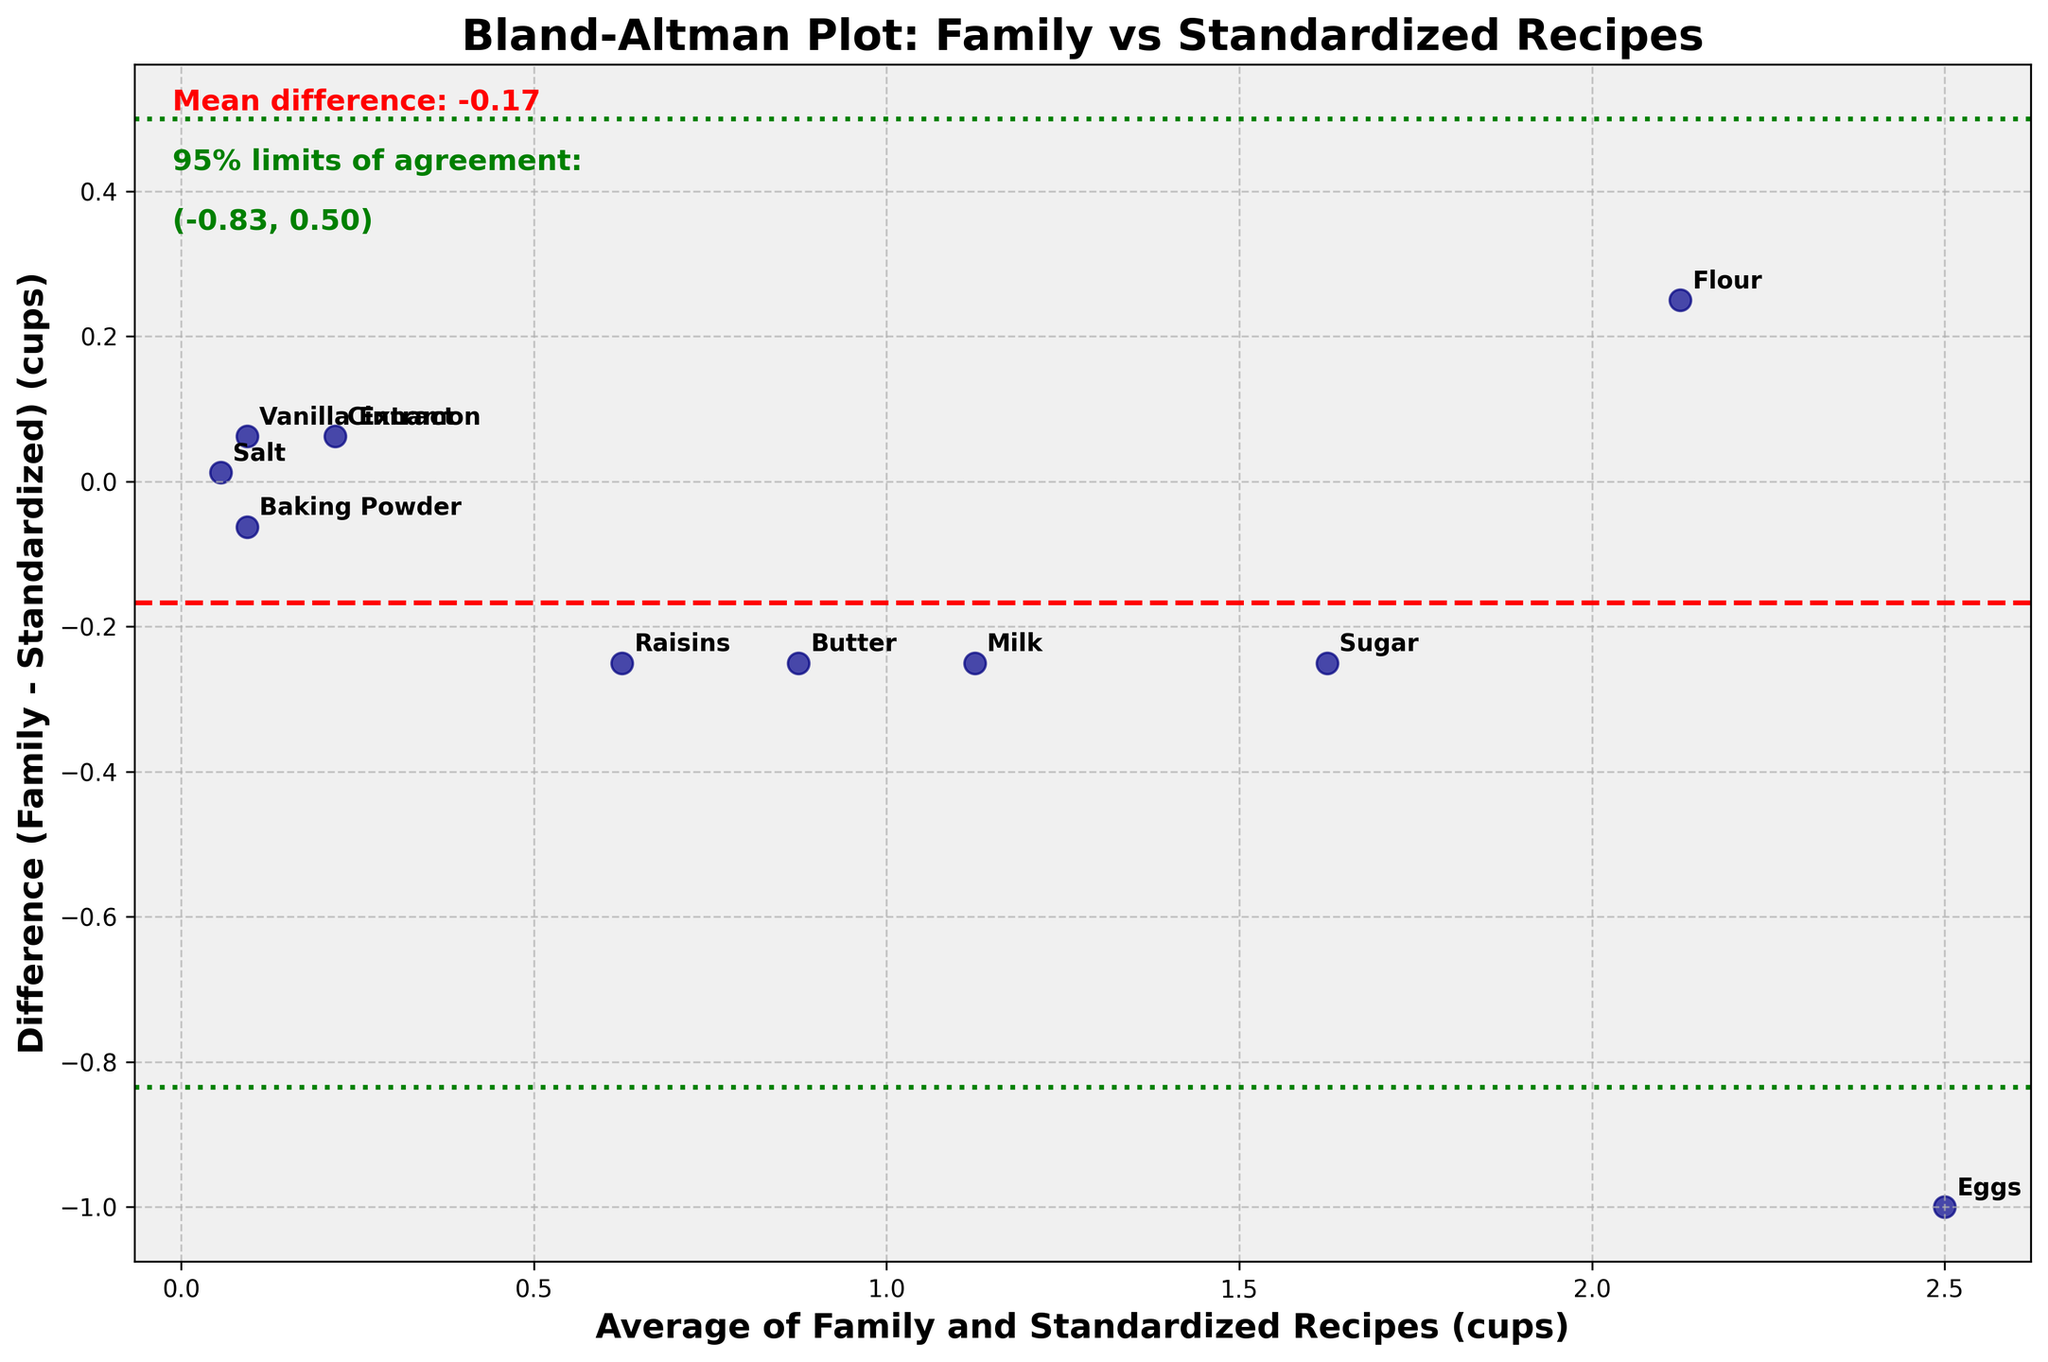What's the title of the plot? The title is located at the top of the plot and usually summarizes the main point of the plot. In this case, it reads "Bland-Altman Plot: Family vs Standardized Recipes."
Answer: Bland-Altman Plot: Family vs Standardized Recipes How many ingredients are compared in the plot? The plot shows several data points, each representing a different ingredient. There are 10 different data points labeled with their ingredient names such as Flour, Sugar, and so on.
Answer: 10 What do the red and green lines represent in the plot? The red line represents the mean difference between the family and standardized recipes, and the green lines represent the 95% limits of agreement, which are the mean difference plus and minus 1.96 times the standard deviation of the differences.
Answer: The red line is the mean difference, and the green lines are the 95% limits of agreement Which ingredient shows the largest positive difference between the family and standardized recipes? By observing the vertical position of the data points against the difference axis, the ingredient "Eggs" shows the largest positive difference because it is the highest point above zero.
Answer: Eggs What's the mean difference value between the family and standardized recipes? The mean difference is indicated by the red dashed line and is also displayed as text on the figure. According to the plot, it is around 0.02 cups.
Answer: 0.02 cups Which ingredient has the smallest average measurement between the family and standardized recipes? The average measurement between the family and standardized recipes is plotted on the x-axis. The ingredient "Salt" has the smallest x-value, hence it has the smallest average measurement.
Answer: Salt What are the 95% limits of agreement for the differences? The 95% limits of agreement are shown as text and green dashed lines on the plot. They are calculated as the mean difference plus and minus 1.96 times the standard deviation and displayed as approximately (-0.52, 0.56).
Answer: (-0.52, 0.56) Is there any ingredient for which the family recipe includes more quantity than the standardized recipe? By examining whether the data points are above the zero difference line, we see that "Eggs", "Flour", and "Cinnamon" are above the line, indicating the family recipe includes more quantity for these ingredients.
Answer: Yes, Eggs, Flour, and Cinnamon Which ingredient has the closest agreement between the family and standardized recipes? The closest agreement would be closest to the zero line on the scale of differences. The ingredient "Salt" shows the smallest difference, making it the closest agreement.
Answer: Salt Does the plot show any general bias in the family recipes compared to the standardized recipes? The general bias can be inferred from the location of the red mean difference line. Since it is close to zero, it suggests there is very little general bias in the family recipes compared to the standardized recipes.
Answer: Very little general bias 